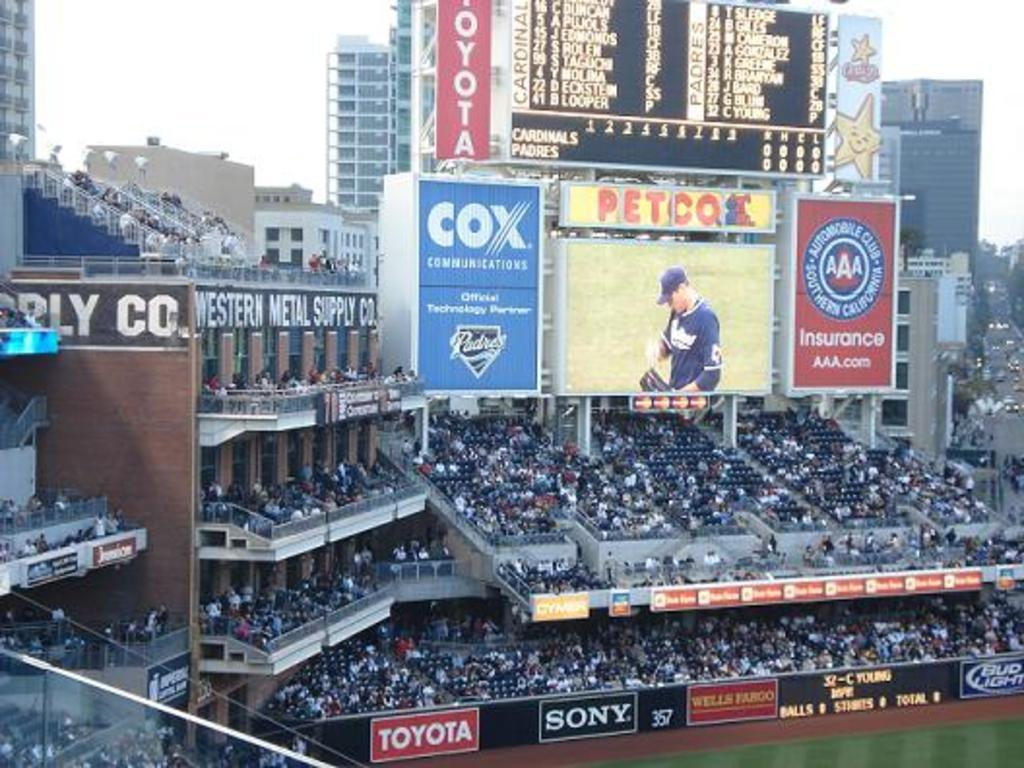<image>
Summarize the visual content of the image. A baseball field and Cox,Petco and Triple A insurance is advertised. 